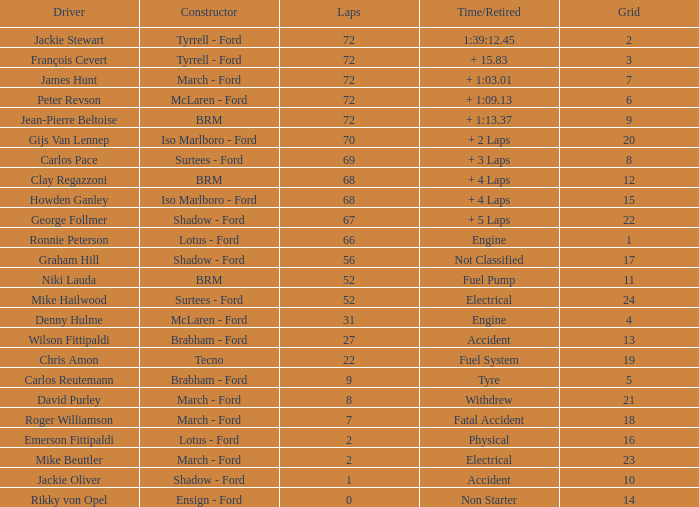Which is the highest-ranked grid with fewer than 66 laps and a retired engine? 4.0. 